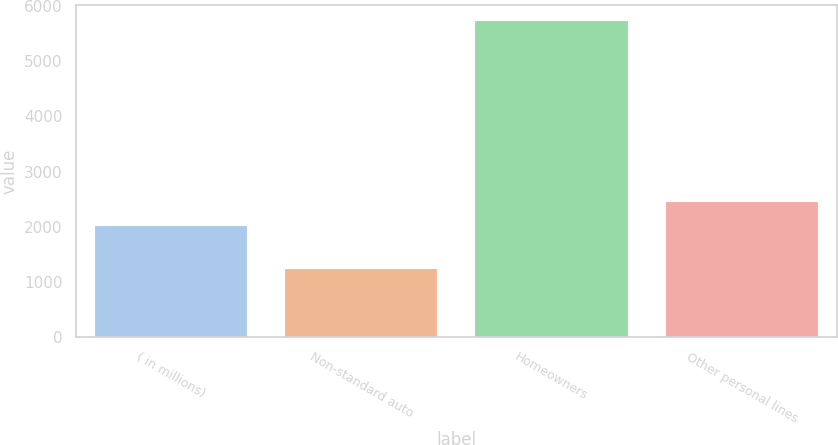Convert chart to OTSL. <chart><loc_0><loc_0><loc_500><loc_500><bar_chart><fcel>( in millions)<fcel>Non-standard auto<fcel>Homeowners<fcel>Other personal lines<nl><fcel>2007<fcel>1232<fcel>5732<fcel>2457<nl></chart> 